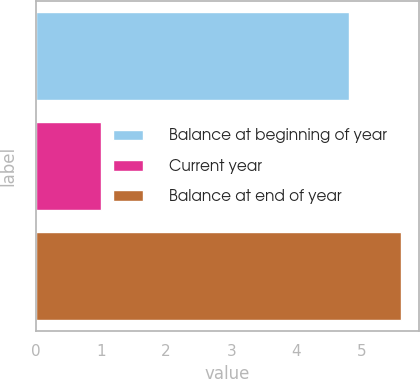Convert chart to OTSL. <chart><loc_0><loc_0><loc_500><loc_500><bar_chart><fcel>Balance at beginning of year<fcel>Current year<fcel>Balance at end of year<nl><fcel>4.8<fcel>1<fcel>5.6<nl></chart> 